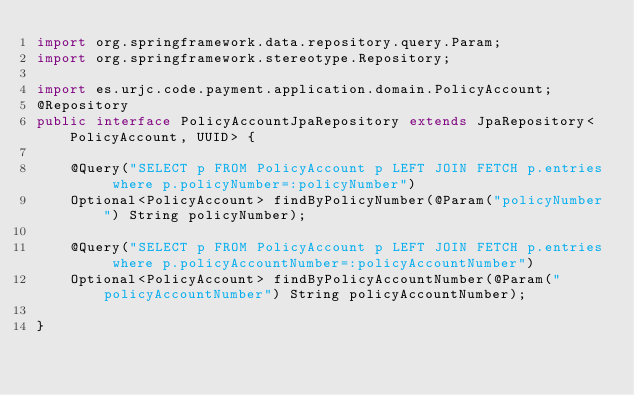Convert code to text. <code><loc_0><loc_0><loc_500><loc_500><_Java_>import org.springframework.data.repository.query.Param;
import org.springframework.stereotype.Repository;

import es.urjc.code.payment.application.domain.PolicyAccount;
@Repository
public interface PolicyAccountJpaRepository extends JpaRepository<PolicyAccount, UUID> {
	
	@Query("SELECT p FROM PolicyAccount p LEFT JOIN FETCH p.entries where p.policyNumber=:policyNumber")
	Optional<PolicyAccount> findByPolicyNumber(@Param("policyNumber") String policyNumber);
	
	@Query("SELECT p FROM PolicyAccount p LEFT JOIN FETCH p.entries where p.policyAccountNumber=:policyAccountNumber")
	Optional<PolicyAccount> findByPolicyAccountNumber(@Param("policyAccountNumber") String policyAccountNumber);

}
</code> 